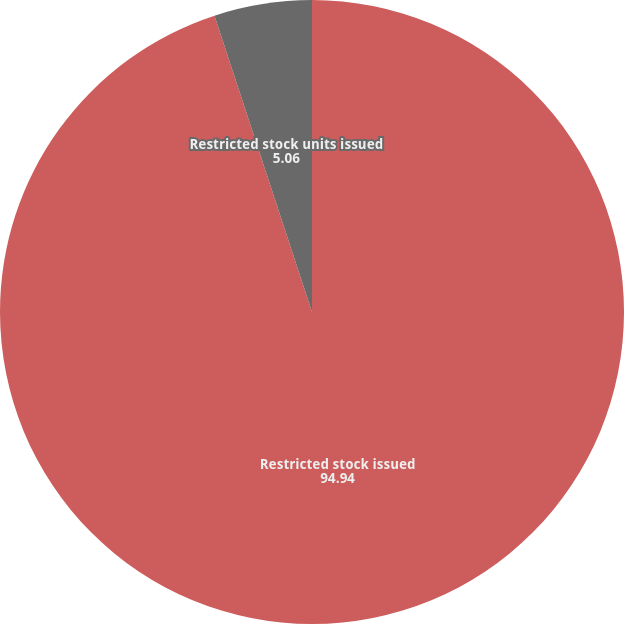Convert chart to OTSL. <chart><loc_0><loc_0><loc_500><loc_500><pie_chart><fcel>Restricted stock issued<fcel>Restricted stock units issued<nl><fcel>94.94%<fcel>5.06%<nl></chart> 